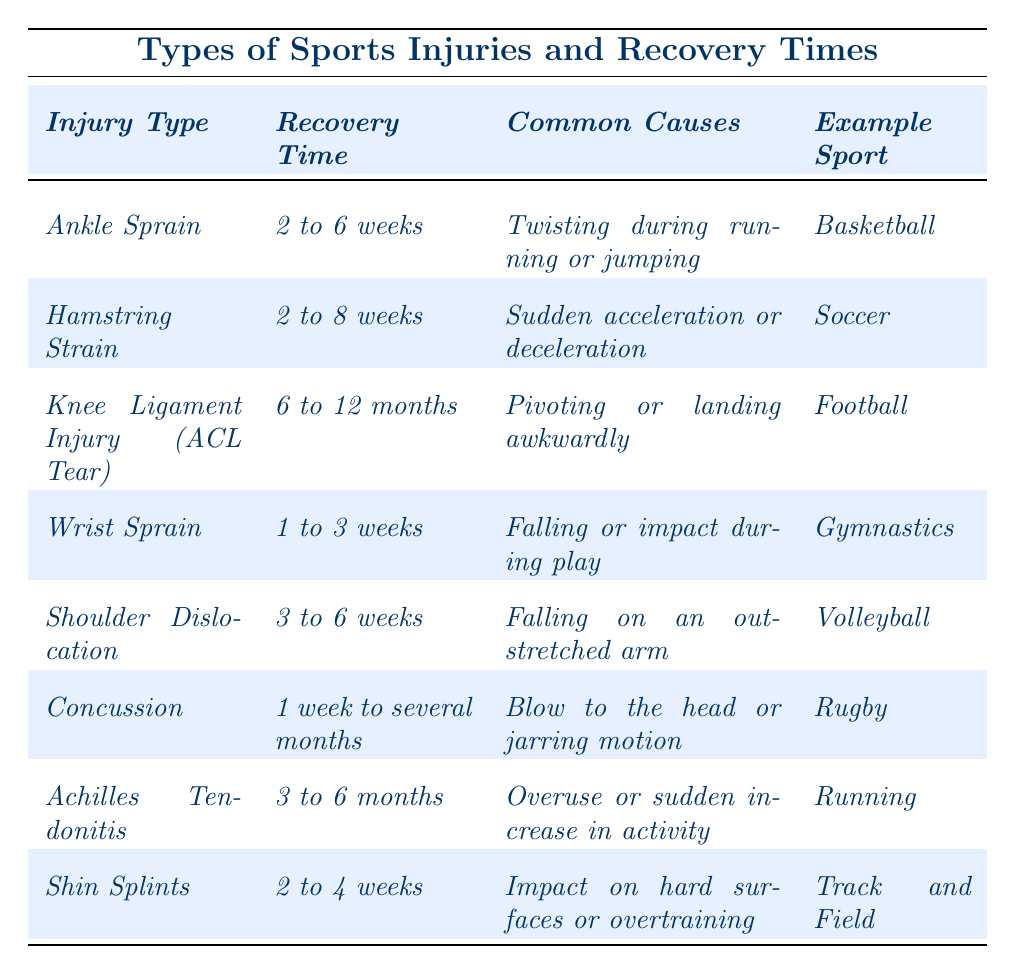What is the recovery time for an ankle sprain? The table lists the average recovery time for an ankle sprain as 2 to 6 weeks.
Answer: 2 to 6 weeks Which injury has the longest recovery time? The table shows that the knee ligament injury (ACL tear) has the longest recovery time, which is 6 to 12 months.
Answer: 6 to 12 months Is a wrist sprain generally more serious than a concussion? By comparing the recovery times, a wrist sprain has an average recovery time of 1 to 3 weeks while a concussion can take 1 week to several months, indicating that a concussion can potentially be more serious.
Answer: No What is the average recovery time for shin splints and wrist sprains combined? The recovery time for shin splints is 2 to 4 weeks, and for wrist sprains, it is 1 to 3 weeks. The average of the midpoints (3 weeks for shin splints and 2 weeks for wrist sprains) is (3 + 2) / 2 = 2.5 weeks.
Answer: 2.5 weeks What common causes are associated with a hamstring strain? The table states that hamstring strains are commonly caused by sudden acceleration or deceleration.
Answer: Sudden acceleration or deceleration If someone is playing volleyball, what is the potential injury they might avoid if they take precautions? The table indicates that volleyball can lead to shoulder dislocations due to falling on an outstretched arm, so precautions can help avoid this injury.
Answer: Shoulder dislocation How many injuries listed have a recovery time of less than 4 weeks? Referring to the table, both wrist sprains (1 to 3 weeks) and shin splints (2 to 4 weeks) have recovery times less than 4 weeks. Therefore, there are 2 injuries.
Answer: 2 injuries What is the average recovery time for injuries that are common in running sports? Running sports include ankle sprains (2 to 6 weeks), Achilles tendonitis (3 to 6 months), and hamstring strains (2 to 8 weeks). Calculating timestamps, the midpoints are 4 weeks, 4.5 months (or 18 weeks), and 5 weeks, respectively. Average recovery time is (4 + 18 + 5) / 3 = 9 weeks.
Answer: 9 weeks Are athletes in football more likely to face a long recovery time compared to athletes in gymnastics? Athletes in football may experience knee ligament injuries (6 to 12 months), while those in gymnastics may face wrist sprains (1 to 3 weeks), making football injuries likely to require a longer recovery time.
Answer: Yes What sports injury is most likely to occur due to falling? Based on the table, a wrist sprain and a shoulder dislocation occur due to falling; however, shoulder dislocation is explicitly linked to falling on an outstretched arm, making it the most likely.
Answer: Shoulder dislocation 